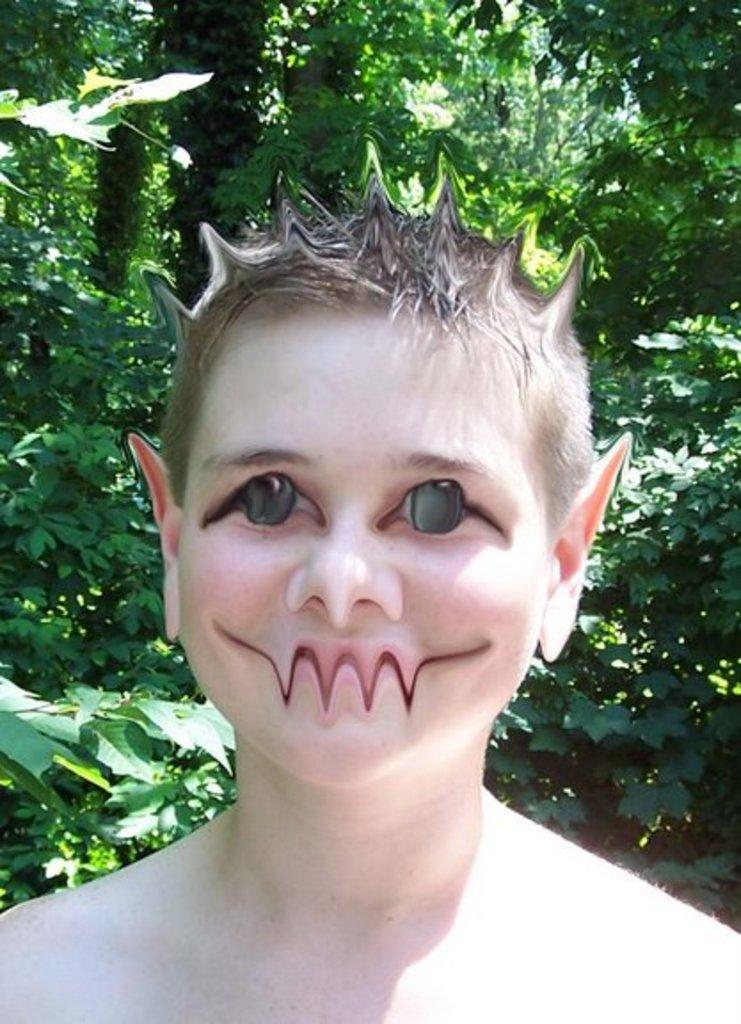What is the main subject in the center of the image? There is a boy in the center of the image. What can be seen in the background of the image? There are trees in the background of the image. What is the boy's monthly income in the image? There is no information about the boy's income in the image. 